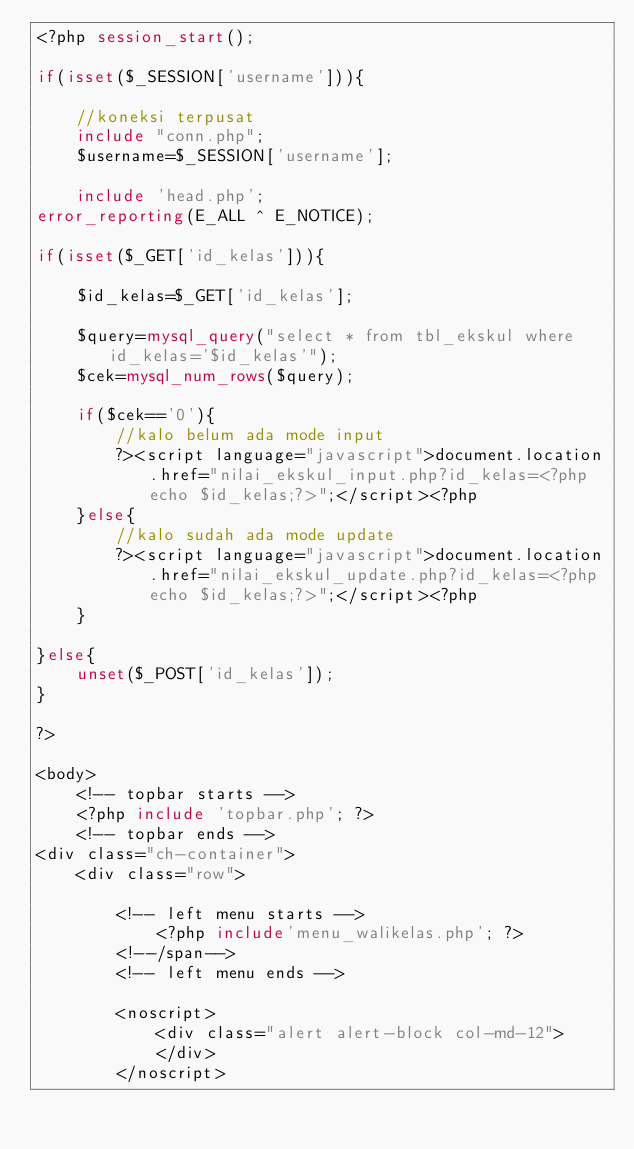Convert code to text. <code><loc_0><loc_0><loc_500><loc_500><_PHP_><?php session_start();

if(isset($_SESSION['username'])){

    //koneksi terpusat
    include "conn.php";
    $username=$_SESSION['username'];

    include 'head.php'; 
error_reporting(E_ALL ^ E_NOTICE);

if(isset($_GET['id_kelas'])){

    $id_kelas=$_GET['id_kelas'];
    
    $query=mysql_query("select * from tbl_ekskul where id_kelas='$id_kelas'");
    $cek=mysql_num_rows($query);
    
    if($cek=='0'){
        //kalo belum ada mode input
        ?><script language="javascript">document.location.href="nilai_ekskul_input.php?id_kelas=<?php echo $id_kelas;?>";</script><?php
    }else{
        //kalo sudah ada mode update
        ?><script language="javascript">document.location.href="nilai_ekskul_update.php?id_kelas=<?php echo $id_kelas;?>";</script><?php
    }

}else{
    unset($_POST['id_kelas']);
}

?>

<body>
    <!-- topbar starts -->
    <?php include 'topbar.php'; ?>
    <!-- topbar ends -->
<div class="ch-container">
    <div class="row">
        
        <!-- left menu starts -->
            <?php include'menu_walikelas.php'; ?>
        <!--/span-->
        <!-- left menu ends -->

        <noscript>
            <div class="alert alert-block col-md-12">
            </div>
        </noscript>
</code> 